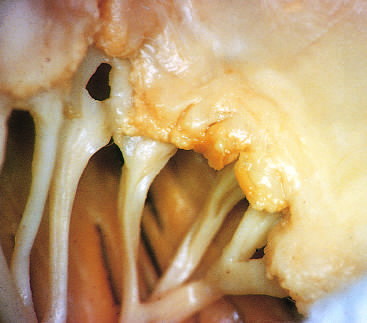s granulation tissue superimposed on chronic rheumatic heart disease?
Answer the question using a single word or phrase. No 